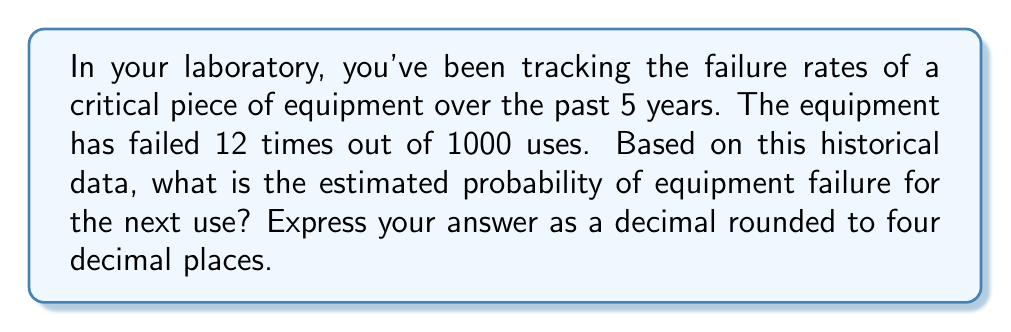Solve this math problem. To estimate the probability of equipment failure based on historical data, we can use the concept of relative frequency as an approximation of probability. Here's how we can approach this problem:

1. Identify the total number of trials (uses of the equipment):
   $n = 1000$

2. Identify the number of times the event of interest occurred (equipment failures):
   $k = 12$

3. Calculate the relative frequency using the formula:
   $$P(\text{failure}) \approx \frac{\text{number of failures}}{\text{total number of uses}}$$

4. Plug in the values:
   $$P(\text{failure}) \approx \frac{12}{1000}$$

5. Perform the division:
   $$P(\text{failure}) \approx 0.012$$

6. Round to four decimal places:
   $$P(\text{failure}) \approx 0.0120$$

Therefore, based on the historical data, the estimated probability of equipment failure for the next use is 0.0120 or 1.20%.
Answer: 0.0120 